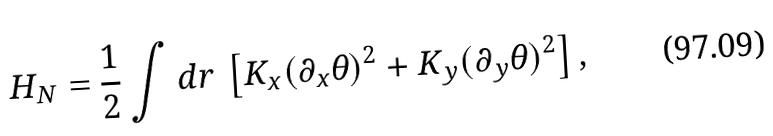Convert formula to latex. <formula><loc_0><loc_0><loc_500><loc_500>H _ { N } = \frac { 1 } { 2 } \int d { r } \, \left [ K _ { x } ( \partial _ { x } \theta ) ^ { 2 } + K _ { y } ( \partial _ { y } \theta ) ^ { 2 } \right ] ,</formula> 